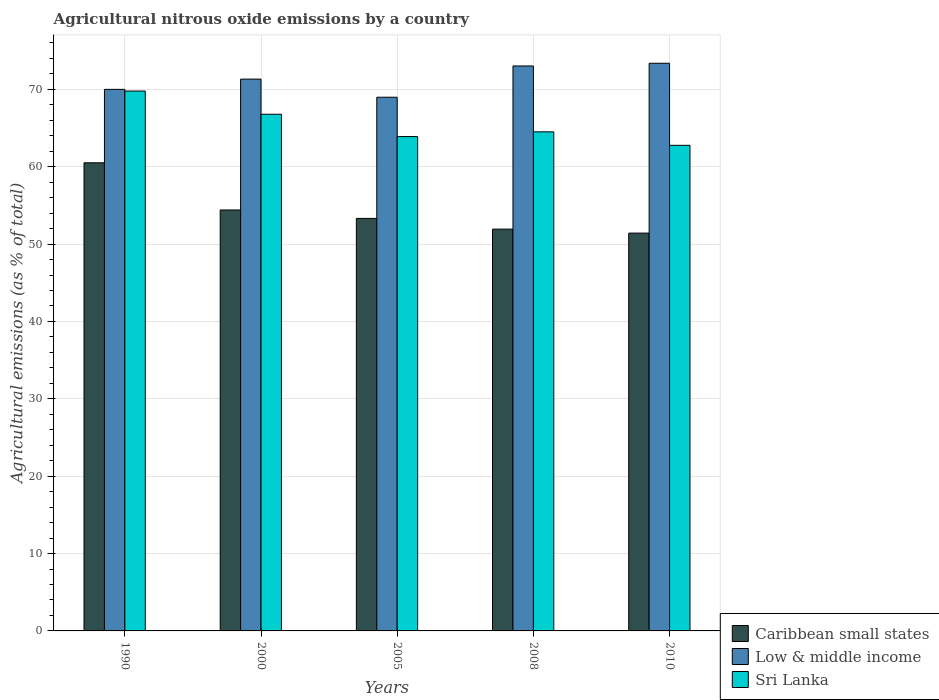Are the number of bars per tick equal to the number of legend labels?
Your response must be concise. Yes. Are the number of bars on each tick of the X-axis equal?
Keep it short and to the point. Yes. How many bars are there on the 2nd tick from the left?
Provide a succinct answer. 3. What is the label of the 1st group of bars from the left?
Your answer should be compact. 1990. In how many cases, is the number of bars for a given year not equal to the number of legend labels?
Your response must be concise. 0. What is the amount of agricultural nitrous oxide emitted in Caribbean small states in 2008?
Ensure brevity in your answer.  51.93. Across all years, what is the maximum amount of agricultural nitrous oxide emitted in Sri Lanka?
Your answer should be compact. 69.78. Across all years, what is the minimum amount of agricultural nitrous oxide emitted in Sri Lanka?
Your response must be concise. 62.77. In which year was the amount of agricultural nitrous oxide emitted in Low & middle income minimum?
Make the answer very short. 2005. What is the total amount of agricultural nitrous oxide emitted in Caribbean small states in the graph?
Provide a short and direct response. 271.59. What is the difference between the amount of agricultural nitrous oxide emitted in Caribbean small states in 1990 and that in 2008?
Ensure brevity in your answer.  8.57. What is the difference between the amount of agricultural nitrous oxide emitted in Caribbean small states in 2008 and the amount of agricultural nitrous oxide emitted in Low & middle income in 2005?
Your answer should be very brief. -17.05. What is the average amount of agricultural nitrous oxide emitted in Sri Lanka per year?
Offer a very short reply. 65.55. In the year 1990, what is the difference between the amount of agricultural nitrous oxide emitted in Low & middle income and amount of agricultural nitrous oxide emitted in Sri Lanka?
Ensure brevity in your answer.  0.22. What is the ratio of the amount of agricultural nitrous oxide emitted in Low & middle income in 2000 to that in 2010?
Your answer should be very brief. 0.97. Is the amount of agricultural nitrous oxide emitted in Caribbean small states in 1990 less than that in 2005?
Keep it short and to the point. No. Is the difference between the amount of agricultural nitrous oxide emitted in Low & middle income in 2008 and 2010 greater than the difference between the amount of agricultural nitrous oxide emitted in Sri Lanka in 2008 and 2010?
Keep it short and to the point. No. What is the difference between the highest and the second highest amount of agricultural nitrous oxide emitted in Sri Lanka?
Your answer should be compact. 3. What is the difference between the highest and the lowest amount of agricultural nitrous oxide emitted in Low & middle income?
Your response must be concise. 4.39. Is the sum of the amount of agricultural nitrous oxide emitted in Sri Lanka in 2000 and 2010 greater than the maximum amount of agricultural nitrous oxide emitted in Caribbean small states across all years?
Your answer should be compact. Yes. What does the 3rd bar from the left in 2008 represents?
Offer a terse response. Sri Lanka. What does the 2nd bar from the right in 2008 represents?
Give a very brief answer. Low & middle income. Is it the case that in every year, the sum of the amount of agricultural nitrous oxide emitted in Caribbean small states and amount of agricultural nitrous oxide emitted in Low & middle income is greater than the amount of agricultural nitrous oxide emitted in Sri Lanka?
Make the answer very short. Yes. How many bars are there?
Your answer should be very brief. 15. Are all the bars in the graph horizontal?
Provide a short and direct response. No. How many years are there in the graph?
Ensure brevity in your answer.  5. Does the graph contain any zero values?
Your response must be concise. No. Where does the legend appear in the graph?
Offer a very short reply. Bottom right. What is the title of the graph?
Make the answer very short. Agricultural nitrous oxide emissions by a country. What is the label or title of the Y-axis?
Your answer should be very brief. Agricultural emissions (as % of total). What is the Agricultural emissions (as % of total) of Caribbean small states in 1990?
Your answer should be compact. 60.51. What is the Agricultural emissions (as % of total) of Low & middle income in 1990?
Offer a terse response. 70. What is the Agricultural emissions (as % of total) in Sri Lanka in 1990?
Give a very brief answer. 69.78. What is the Agricultural emissions (as % of total) of Caribbean small states in 2000?
Provide a short and direct response. 54.41. What is the Agricultural emissions (as % of total) of Low & middle income in 2000?
Give a very brief answer. 71.32. What is the Agricultural emissions (as % of total) in Sri Lanka in 2000?
Your response must be concise. 66.78. What is the Agricultural emissions (as % of total) in Caribbean small states in 2005?
Offer a very short reply. 53.32. What is the Agricultural emissions (as % of total) in Low & middle income in 2005?
Make the answer very short. 68.98. What is the Agricultural emissions (as % of total) in Sri Lanka in 2005?
Provide a short and direct response. 63.9. What is the Agricultural emissions (as % of total) in Caribbean small states in 2008?
Your answer should be compact. 51.93. What is the Agricultural emissions (as % of total) in Low & middle income in 2008?
Offer a very short reply. 73.02. What is the Agricultural emissions (as % of total) of Sri Lanka in 2008?
Offer a terse response. 64.51. What is the Agricultural emissions (as % of total) of Caribbean small states in 2010?
Your answer should be compact. 51.42. What is the Agricultural emissions (as % of total) of Low & middle income in 2010?
Keep it short and to the point. 73.37. What is the Agricultural emissions (as % of total) of Sri Lanka in 2010?
Provide a succinct answer. 62.77. Across all years, what is the maximum Agricultural emissions (as % of total) in Caribbean small states?
Your response must be concise. 60.51. Across all years, what is the maximum Agricultural emissions (as % of total) of Low & middle income?
Give a very brief answer. 73.37. Across all years, what is the maximum Agricultural emissions (as % of total) of Sri Lanka?
Your answer should be compact. 69.78. Across all years, what is the minimum Agricultural emissions (as % of total) in Caribbean small states?
Keep it short and to the point. 51.42. Across all years, what is the minimum Agricultural emissions (as % of total) in Low & middle income?
Make the answer very short. 68.98. Across all years, what is the minimum Agricultural emissions (as % of total) of Sri Lanka?
Your answer should be compact. 62.77. What is the total Agricultural emissions (as % of total) in Caribbean small states in the graph?
Offer a terse response. 271.59. What is the total Agricultural emissions (as % of total) in Low & middle income in the graph?
Provide a short and direct response. 356.7. What is the total Agricultural emissions (as % of total) of Sri Lanka in the graph?
Make the answer very short. 327.73. What is the difference between the Agricultural emissions (as % of total) in Caribbean small states in 1990 and that in 2000?
Offer a very short reply. 6.1. What is the difference between the Agricultural emissions (as % of total) in Low & middle income in 1990 and that in 2000?
Give a very brief answer. -1.33. What is the difference between the Agricultural emissions (as % of total) in Sri Lanka in 1990 and that in 2000?
Provide a short and direct response. 3. What is the difference between the Agricultural emissions (as % of total) of Caribbean small states in 1990 and that in 2005?
Your answer should be compact. 7.19. What is the difference between the Agricultural emissions (as % of total) in Low & middle income in 1990 and that in 2005?
Provide a succinct answer. 1.02. What is the difference between the Agricultural emissions (as % of total) in Sri Lanka in 1990 and that in 2005?
Your answer should be compact. 5.88. What is the difference between the Agricultural emissions (as % of total) of Caribbean small states in 1990 and that in 2008?
Offer a terse response. 8.57. What is the difference between the Agricultural emissions (as % of total) in Low & middle income in 1990 and that in 2008?
Ensure brevity in your answer.  -3.03. What is the difference between the Agricultural emissions (as % of total) in Sri Lanka in 1990 and that in 2008?
Offer a very short reply. 5.27. What is the difference between the Agricultural emissions (as % of total) in Caribbean small states in 1990 and that in 2010?
Ensure brevity in your answer.  9.09. What is the difference between the Agricultural emissions (as % of total) of Low & middle income in 1990 and that in 2010?
Give a very brief answer. -3.37. What is the difference between the Agricultural emissions (as % of total) in Sri Lanka in 1990 and that in 2010?
Provide a succinct answer. 7.01. What is the difference between the Agricultural emissions (as % of total) of Caribbean small states in 2000 and that in 2005?
Offer a very short reply. 1.09. What is the difference between the Agricultural emissions (as % of total) in Low & middle income in 2000 and that in 2005?
Your answer should be compact. 2.34. What is the difference between the Agricultural emissions (as % of total) of Sri Lanka in 2000 and that in 2005?
Give a very brief answer. 2.88. What is the difference between the Agricultural emissions (as % of total) in Caribbean small states in 2000 and that in 2008?
Your response must be concise. 2.47. What is the difference between the Agricultural emissions (as % of total) in Low & middle income in 2000 and that in 2008?
Your response must be concise. -1.7. What is the difference between the Agricultural emissions (as % of total) of Sri Lanka in 2000 and that in 2008?
Your response must be concise. 2.27. What is the difference between the Agricultural emissions (as % of total) of Caribbean small states in 2000 and that in 2010?
Make the answer very short. 2.99. What is the difference between the Agricultural emissions (as % of total) in Low & middle income in 2000 and that in 2010?
Ensure brevity in your answer.  -2.05. What is the difference between the Agricultural emissions (as % of total) in Sri Lanka in 2000 and that in 2010?
Ensure brevity in your answer.  4.01. What is the difference between the Agricultural emissions (as % of total) in Caribbean small states in 2005 and that in 2008?
Provide a short and direct response. 1.39. What is the difference between the Agricultural emissions (as % of total) of Low & middle income in 2005 and that in 2008?
Give a very brief answer. -4.04. What is the difference between the Agricultural emissions (as % of total) in Sri Lanka in 2005 and that in 2008?
Provide a short and direct response. -0.61. What is the difference between the Agricultural emissions (as % of total) in Caribbean small states in 2005 and that in 2010?
Offer a very short reply. 1.9. What is the difference between the Agricultural emissions (as % of total) in Low & middle income in 2005 and that in 2010?
Give a very brief answer. -4.39. What is the difference between the Agricultural emissions (as % of total) in Sri Lanka in 2005 and that in 2010?
Provide a short and direct response. 1.13. What is the difference between the Agricultural emissions (as % of total) in Caribbean small states in 2008 and that in 2010?
Provide a succinct answer. 0.51. What is the difference between the Agricultural emissions (as % of total) in Low & middle income in 2008 and that in 2010?
Keep it short and to the point. -0.35. What is the difference between the Agricultural emissions (as % of total) of Sri Lanka in 2008 and that in 2010?
Keep it short and to the point. 1.74. What is the difference between the Agricultural emissions (as % of total) of Caribbean small states in 1990 and the Agricultural emissions (as % of total) of Low & middle income in 2000?
Give a very brief answer. -10.82. What is the difference between the Agricultural emissions (as % of total) of Caribbean small states in 1990 and the Agricultural emissions (as % of total) of Sri Lanka in 2000?
Provide a short and direct response. -6.27. What is the difference between the Agricultural emissions (as % of total) of Low & middle income in 1990 and the Agricultural emissions (as % of total) of Sri Lanka in 2000?
Offer a terse response. 3.22. What is the difference between the Agricultural emissions (as % of total) of Caribbean small states in 1990 and the Agricultural emissions (as % of total) of Low & middle income in 2005?
Keep it short and to the point. -8.48. What is the difference between the Agricultural emissions (as % of total) in Caribbean small states in 1990 and the Agricultural emissions (as % of total) in Sri Lanka in 2005?
Provide a succinct answer. -3.39. What is the difference between the Agricultural emissions (as % of total) in Low & middle income in 1990 and the Agricultural emissions (as % of total) in Sri Lanka in 2005?
Provide a succinct answer. 6.1. What is the difference between the Agricultural emissions (as % of total) in Caribbean small states in 1990 and the Agricultural emissions (as % of total) in Low & middle income in 2008?
Your response must be concise. -12.52. What is the difference between the Agricultural emissions (as % of total) in Caribbean small states in 1990 and the Agricultural emissions (as % of total) in Sri Lanka in 2008?
Offer a very short reply. -4. What is the difference between the Agricultural emissions (as % of total) of Low & middle income in 1990 and the Agricultural emissions (as % of total) of Sri Lanka in 2008?
Provide a succinct answer. 5.49. What is the difference between the Agricultural emissions (as % of total) of Caribbean small states in 1990 and the Agricultural emissions (as % of total) of Low & middle income in 2010?
Give a very brief answer. -12.87. What is the difference between the Agricultural emissions (as % of total) of Caribbean small states in 1990 and the Agricultural emissions (as % of total) of Sri Lanka in 2010?
Give a very brief answer. -2.26. What is the difference between the Agricultural emissions (as % of total) in Low & middle income in 1990 and the Agricultural emissions (as % of total) in Sri Lanka in 2010?
Offer a very short reply. 7.23. What is the difference between the Agricultural emissions (as % of total) of Caribbean small states in 2000 and the Agricultural emissions (as % of total) of Low & middle income in 2005?
Make the answer very short. -14.57. What is the difference between the Agricultural emissions (as % of total) of Caribbean small states in 2000 and the Agricultural emissions (as % of total) of Sri Lanka in 2005?
Make the answer very short. -9.49. What is the difference between the Agricultural emissions (as % of total) of Low & middle income in 2000 and the Agricultural emissions (as % of total) of Sri Lanka in 2005?
Your response must be concise. 7.43. What is the difference between the Agricultural emissions (as % of total) in Caribbean small states in 2000 and the Agricultural emissions (as % of total) in Low & middle income in 2008?
Your answer should be very brief. -18.61. What is the difference between the Agricultural emissions (as % of total) in Caribbean small states in 2000 and the Agricultural emissions (as % of total) in Sri Lanka in 2008?
Your answer should be very brief. -10.1. What is the difference between the Agricultural emissions (as % of total) of Low & middle income in 2000 and the Agricultural emissions (as % of total) of Sri Lanka in 2008?
Your response must be concise. 6.82. What is the difference between the Agricultural emissions (as % of total) in Caribbean small states in 2000 and the Agricultural emissions (as % of total) in Low & middle income in 2010?
Your answer should be compact. -18.96. What is the difference between the Agricultural emissions (as % of total) in Caribbean small states in 2000 and the Agricultural emissions (as % of total) in Sri Lanka in 2010?
Your response must be concise. -8.36. What is the difference between the Agricultural emissions (as % of total) in Low & middle income in 2000 and the Agricultural emissions (as % of total) in Sri Lanka in 2010?
Keep it short and to the point. 8.56. What is the difference between the Agricultural emissions (as % of total) in Caribbean small states in 2005 and the Agricultural emissions (as % of total) in Low & middle income in 2008?
Provide a succinct answer. -19.7. What is the difference between the Agricultural emissions (as % of total) of Caribbean small states in 2005 and the Agricultural emissions (as % of total) of Sri Lanka in 2008?
Provide a succinct answer. -11.19. What is the difference between the Agricultural emissions (as % of total) in Low & middle income in 2005 and the Agricultural emissions (as % of total) in Sri Lanka in 2008?
Provide a short and direct response. 4.48. What is the difference between the Agricultural emissions (as % of total) in Caribbean small states in 2005 and the Agricultural emissions (as % of total) in Low & middle income in 2010?
Your answer should be compact. -20.05. What is the difference between the Agricultural emissions (as % of total) in Caribbean small states in 2005 and the Agricultural emissions (as % of total) in Sri Lanka in 2010?
Make the answer very short. -9.45. What is the difference between the Agricultural emissions (as % of total) in Low & middle income in 2005 and the Agricultural emissions (as % of total) in Sri Lanka in 2010?
Provide a succinct answer. 6.22. What is the difference between the Agricultural emissions (as % of total) of Caribbean small states in 2008 and the Agricultural emissions (as % of total) of Low & middle income in 2010?
Provide a short and direct response. -21.44. What is the difference between the Agricultural emissions (as % of total) of Caribbean small states in 2008 and the Agricultural emissions (as % of total) of Sri Lanka in 2010?
Provide a short and direct response. -10.83. What is the difference between the Agricultural emissions (as % of total) of Low & middle income in 2008 and the Agricultural emissions (as % of total) of Sri Lanka in 2010?
Provide a succinct answer. 10.26. What is the average Agricultural emissions (as % of total) of Caribbean small states per year?
Provide a succinct answer. 54.32. What is the average Agricultural emissions (as % of total) of Low & middle income per year?
Ensure brevity in your answer.  71.34. What is the average Agricultural emissions (as % of total) of Sri Lanka per year?
Make the answer very short. 65.55. In the year 1990, what is the difference between the Agricultural emissions (as % of total) in Caribbean small states and Agricultural emissions (as % of total) in Low & middle income?
Offer a very short reply. -9.49. In the year 1990, what is the difference between the Agricultural emissions (as % of total) in Caribbean small states and Agricultural emissions (as % of total) in Sri Lanka?
Your response must be concise. -9.27. In the year 1990, what is the difference between the Agricultural emissions (as % of total) in Low & middle income and Agricultural emissions (as % of total) in Sri Lanka?
Give a very brief answer. 0.22. In the year 2000, what is the difference between the Agricultural emissions (as % of total) in Caribbean small states and Agricultural emissions (as % of total) in Low & middle income?
Provide a short and direct response. -16.92. In the year 2000, what is the difference between the Agricultural emissions (as % of total) of Caribbean small states and Agricultural emissions (as % of total) of Sri Lanka?
Make the answer very short. -12.37. In the year 2000, what is the difference between the Agricultural emissions (as % of total) of Low & middle income and Agricultural emissions (as % of total) of Sri Lanka?
Offer a very short reply. 4.54. In the year 2005, what is the difference between the Agricultural emissions (as % of total) of Caribbean small states and Agricultural emissions (as % of total) of Low & middle income?
Your response must be concise. -15.66. In the year 2005, what is the difference between the Agricultural emissions (as % of total) in Caribbean small states and Agricultural emissions (as % of total) in Sri Lanka?
Make the answer very short. -10.58. In the year 2005, what is the difference between the Agricultural emissions (as % of total) in Low & middle income and Agricultural emissions (as % of total) in Sri Lanka?
Ensure brevity in your answer.  5.08. In the year 2008, what is the difference between the Agricultural emissions (as % of total) in Caribbean small states and Agricultural emissions (as % of total) in Low & middle income?
Offer a very short reply. -21.09. In the year 2008, what is the difference between the Agricultural emissions (as % of total) of Caribbean small states and Agricultural emissions (as % of total) of Sri Lanka?
Give a very brief answer. -12.57. In the year 2008, what is the difference between the Agricultural emissions (as % of total) of Low & middle income and Agricultural emissions (as % of total) of Sri Lanka?
Your answer should be compact. 8.52. In the year 2010, what is the difference between the Agricultural emissions (as % of total) in Caribbean small states and Agricultural emissions (as % of total) in Low & middle income?
Provide a short and direct response. -21.95. In the year 2010, what is the difference between the Agricultural emissions (as % of total) of Caribbean small states and Agricultural emissions (as % of total) of Sri Lanka?
Your answer should be compact. -11.35. In the year 2010, what is the difference between the Agricultural emissions (as % of total) in Low & middle income and Agricultural emissions (as % of total) in Sri Lanka?
Provide a short and direct response. 10.61. What is the ratio of the Agricultural emissions (as % of total) of Caribbean small states in 1990 to that in 2000?
Provide a short and direct response. 1.11. What is the ratio of the Agricultural emissions (as % of total) of Low & middle income in 1990 to that in 2000?
Provide a short and direct response. 0.98. What is the ratio of the Agricultural emissions (as % of total) of Sri Lanka in 1990 to that in 2000?
Offer a very short reply. 1.04. What is the ratio of the Agricultural emissions (as % of total) in Caribbean small states in 1990 to that in 2005?
Offer a terse response. 1.13. What is the ratio of the Agricultural emissions (as % of total) in Low & middle income in 1990 to that in 2005?
Your answer should be very brief. 1.01. What is the ratio of the Agricultural emissions (as % of total) in Sri Lanka in 1990 to that in 2005?
Your answer should be compact. 1.09. What is the ratio of the Agricultural emissions (as % of total) in Caribbean small states in 1990 to that in 2008?
Offer a terse response. 1.17. What is the ratio of the Agricultural emissions (as % of total) in Low & middle income in 1990 to that in 2008?
Provide a succinct answer. 0.96. What is the ratio of the Agricultural emissions (as % of total) in Sri Lanka in 1990 to that in 2008?
Offer a terse response. 1.08. What is the ratio of the Agricultural emissions (as % of total) of Caribbean small states in 1990 to that in 2010?
Offer a terse response. 1.18. What is the ratio of the Agricultural emissions (as % of total) of Low & middle income in 1990 to that in 2010?
Provide a succinct answer. 0.95. What is the ratio of the Agricultural emissions (as % of total) in Sri Lanka in 1990 to that in 2010?
Provide a short and direct response. 1.11. What is the ratio of the Agricultural emissions (as % of total) of Caribbean small states in 2000 to that in 2005?
Offer a very short reply. 1.02. What is the ratio of the Agricultural emissions (as % of total) in Low & middle income in 2000 to that in 2005?
Your answer should be compact. 1.03. What is the ratio of the Agricultural emissions (as % of total) of Sri Lanka in 2000 to that in 2005?
Your answer should be compact. 1.05. What is the ratio of the Agricultural emissions (as % of total) in Caribbean small states in 2000 to that in 2008?
Your answer should be compact. 1.05. What is the ratio of the Agricultural emissions (as % of total) in Low & middle income in 2000 to that in 2008?
Provide a succinct answer. 0.98. What is the ratio of the Agricultural emissions (as % of total) in Sri Lanka in 2000 to that in 2008?
Ensure brevity in your answer.  1.04. What is the ratio of the Agricultural emissions (as % of total) of Caribbean small states in 2000 to that in 2010?
Offer a very short reply. 1.06. What is the ratio of the Agricultural emissions (as % of total) in Low & middle income in 2000 to that in 2010?
Ensure brevity in your answer.  0.97. What is the ratio of the Agricultural emissions (as % of total) in Sri Lanka in 2000 to that in 2010?
Keep it short and to the point. 1.06. What is the ratio of the Agricultural emissions (as % of total) of Caribbean small states in 2005 to that in 2008?
Keep it short and to the point. 1.03. What is the ratio of the Agricultural emissions (as % of total) of Low & middle income in 2005 to that in 2008?
Offer a terse response. 0.94. What is the ratio of the Agricultural emissions (as % of total) in Sri Lanka in 2005 to that in 2008?
Your answer should be very brief. 0.99. What is the ratio of the Agricultural emissions (as % of total) of Caribbean small states in 2005 to that in 2010?
Provide a short and direct response. 1.04. What is the ratio of the Agricultural emissions (as % of total) in Low & middle income in 2005 to that in 2010?
Your response must be concise. 0.94. What is the ratio of the Agricultural emissions (as % of total) in Sri Lanka in 2005 to that in 2010?
Make the answer very short. 1.02. What is the ratio of the Agricultural emissions (as % of total) in Caribbean small states in 2008 to that in 2010?
Your response must be concise. 1.01. What is the ratio of the Agricultural emissions (as % of total) of Low & middle income in 2008 to that in 2010?
Your answer should be very brief. 1. What is the ratio of the Agricultural emissions (as % of total) of Sri Lanka in 2008 to that in 2010?
Your answer should be compact. 1.03. What is the difference between the highest and the second highest Agricultural emissions (as % of total) in Caribbean small states?
Provide a succinct answer. 6.1. What is the difference between the highest and the second highest Agricultural emissions (as % of total) of Low & middle income?
Make the answer very short. 0.35. What is the difference between the highest and the second highest Agricultural emissions (as % of total) of Sri Lanka?
Provide a short and direct response. 3. What is the difference between the highest and the lowest Agricultural emissions (as % of total) in Caribbean small states?
Provide a succinct answer. 9.09. What is the difference between the highest and the lowest Agricultural emissions (as % of total) of Low & middle income?
Provide a short and direct response. 4.39. What is the difference between the highest and the lowest Agricultural emissions (as % of total) of Sri Lanka?
Keep it short and to the point. 7.01. 